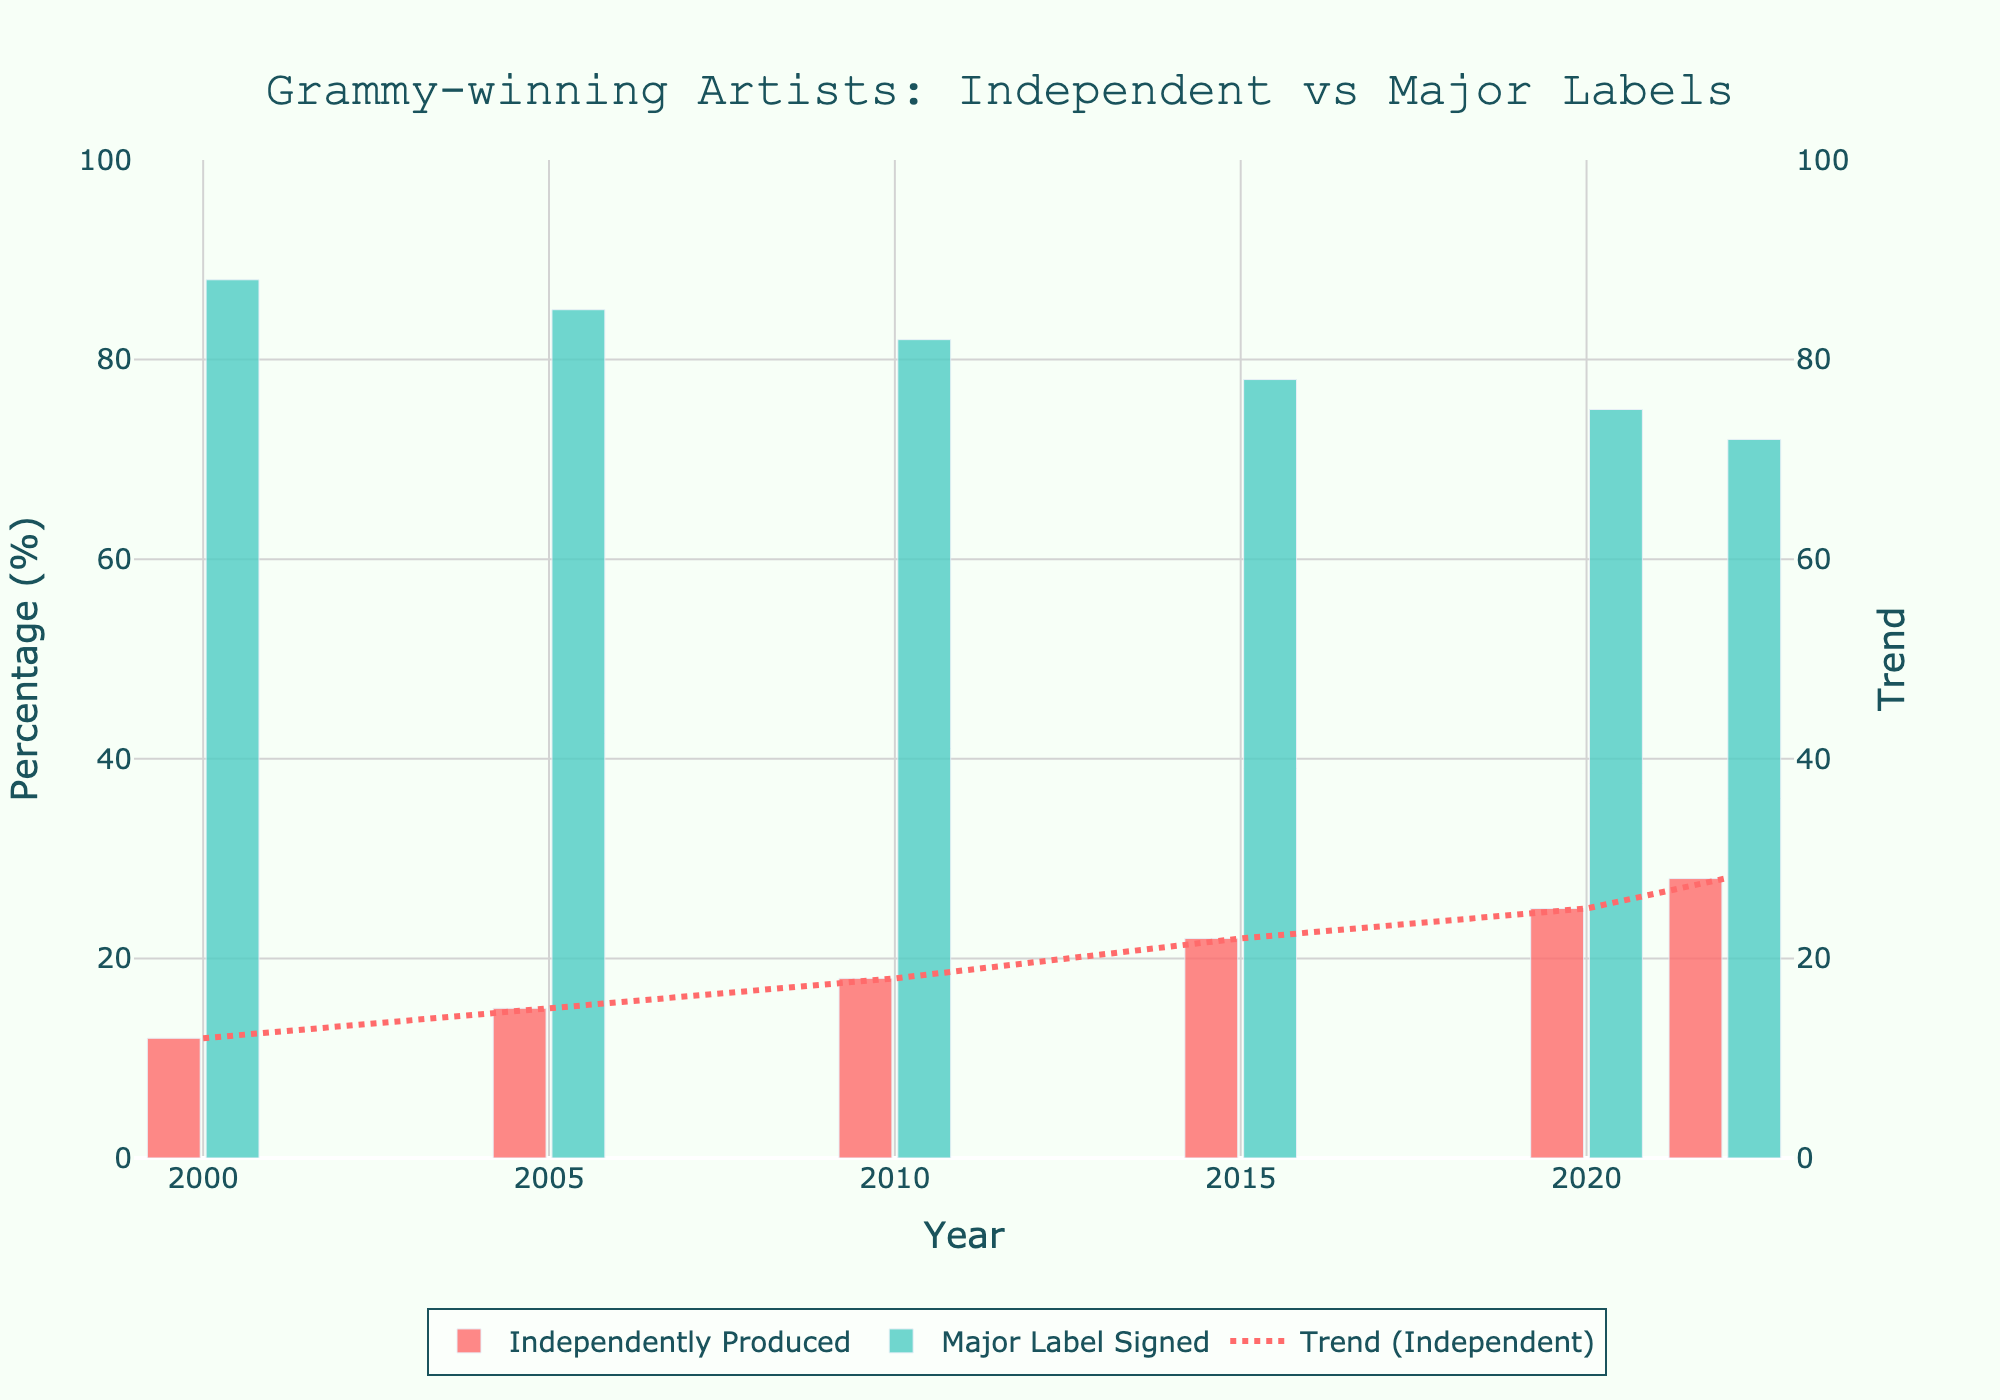What is the trend for independently produced Grammy-winning artists from 2000 to 2022? The trend for independently produced Grammy-winning artists is represented by the red dotted line in the chart. It shows an increasing pattern from 12% in 2000 to 28% in 2022.
Answer: Increasing Compare the percentage of independently produced Grammy-winning artists in 2000 and 2022. What is the difference? To find the difference, subtract the percentage of independently produced Grammy-winning artists in 2000 (12%) from the percentage in 2022 (28%). 28% - 12% = 16%.
Answer: 16% Which year saw the highest percentage of Grammy-winning artists signed to major labels? By visually examining the green bars, 2000 has the highest percentage of Grammy-winning artists signed to major labels, with 88%.
Answer: 2000 How did the percentage of Grammy-winning artists who are independently produced change between 2010 and 2015? In 2010, the percentage was 18%, and by 2015, it had increased to 22%. Calculate the change: 22% - 18% = 4%.
Answer: Increased by 4% What is the relationship between the trends for independently produced and major label signed Grammy-winning artists? The chart shows that as the percentage of independently produced Grammy-winning artists increases (red dotted line), the percentage of those signed to major labels decreases (green bars).
Answer: Inverse relationship Which category (independently produced or major label signed) had a more significant percentage change over the observed period? Independently produced artists increased from 12% in 2000 to 28% in 2022 (a 16% change). Major label signed artists decreased from 88% in 2000 to 72% in 2022 (a 16% change). Both categories had the same absolute percentage change (16%).
Answer: Both had the same change Which year had the nearest equal percentage of independently produced and major label signed Grammy-winning artists? By examining the bar heights, the year 2022 had the nearest equal percentages with 28% independently produced and 72% major label signed, which is the closest to an equal split in the observed data.
Answer: 2022 What is the average percentage of independently produced Grammy-winning artists from 2000 to 2022? Sum the percentages for independently produced artists from 2000 to 2022: (12% + 15% + 18% + 22% + 25% + 28%) = 120%. Divide by the number of years (6): 120% / 6 ≈ 20%.
Answer: 20% If the trend continues, what might be the expected percentage of independently produced Grammy-winning artists in 2025? Observing the increasing trend line from 2000 to 2022, there is an approximate increase of about 3% every 5 years. Thus, adding 3% to the 28% observed in 2022 gives an expected percentage of approximately 31% for 2025.
Answer: 31% What was the percentage difference between independently produced and major label signed Grammy-winning artists in 2005? In 2005, the percentage of independently produced artists was 15%, and major label signed was 85%. The difference is 85% - 15% = 70%.
Answer: 70% 